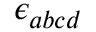<formula> <loc_0><loc_0><loc_500><loc_500>\epsilon _ { a b c d }</formula> 